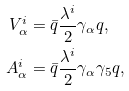<formula> <loc_0><loc_0><loc_500><loc_500>V ^ { i } _ { \alpha } & = \bar { q } \frac { \lambda ^ { i } } { 2 } \gamma _ { \alpha } q , \\ A ^ { i } _ { \alpha } & = \bar { q } \frac { \lambda ^ { i } } { 2 } \gamma _ { \alpha } \gamma _ { 5 } q ,</formula> 